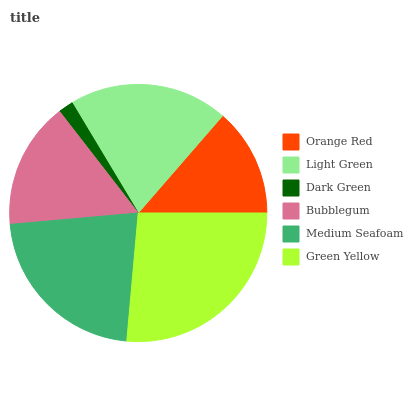Is Dark Green the minimum?
Answer yes or no. Yes. Is Green Yellow the maximum?
Answer yes or no. Yes. Is Light Green the minimum?
Answer yes or no. No. Is Light Green the maximum?
Answer yes or no. No. Is Light Green greater than Orange Red?
Answer yes or no. Yes. Is Orange Red less than Light Green?
Answer yes or no. Yes. Is Orange Red greater than Light Green?
Answer yes or no. No. Is Light Green less than Orange Red?
Answer yes or no. No. Is Light Green the high median?
Answer yes or no. Yes. Is Bubblegum the low median?
Answer yes or no. Yes. Is Dark Green the high median?
Answer yes or no. No. Is Orange Red the low median?
Answer yes or no. No. 